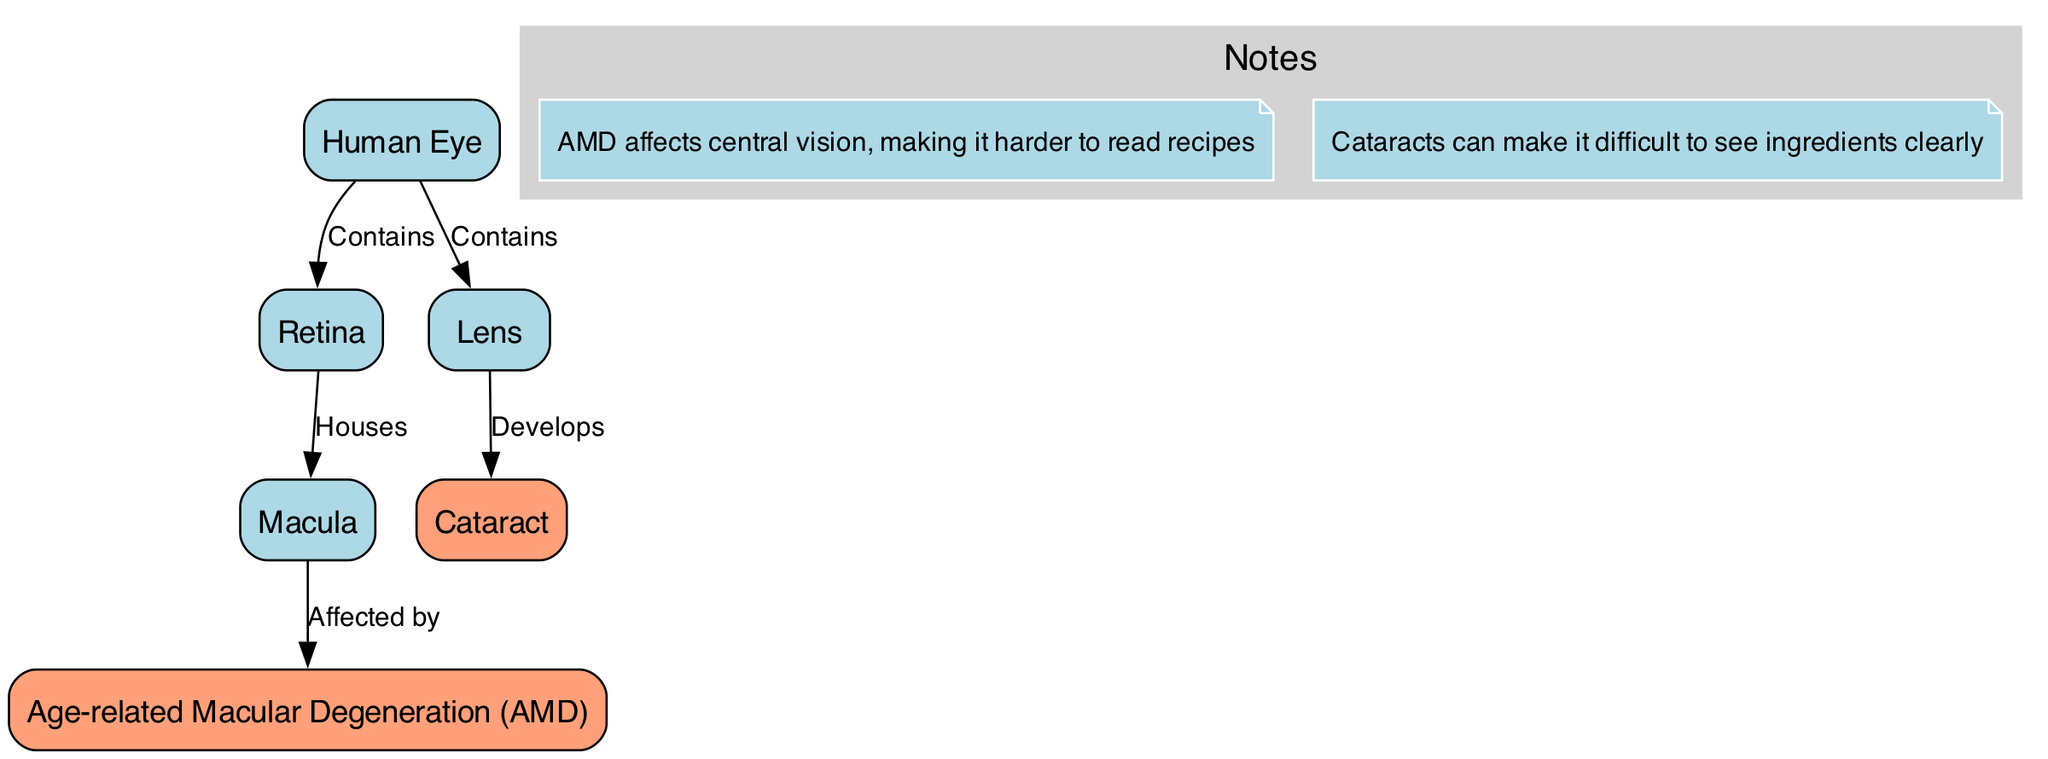What are the two main conditions depicted in the diagram? The diagram features two main conditions: Age-related Macular Degeneration (AMD) and Cataract, which are specified as nodes in the structure.
Answer: Age-related Macular Degeneration, Cataract How many nodes are present in the diagram? By counting the nodes listed in the diagram, we find six in total: Human Eye, Retina, Macula, Age-related Macular Degeneration, Lens, and Cataract.
Answer: 6 What relationship is shown between the Macula and Age-related Macular Degeneration? The diagram indicates that the Macula is affected by Age-related Macular Degeneration, signified by the directional edge from the Macula to the AMD node labeled "Affected by."
Answer: Affected by Which part of the eye contains the Lens according to the diagram? The diagram states that the Human Eye contains the Lens, with a direct edge linking the Eye node to the Lens node labeled "Contains."
Answer: Human Eye What is the effect of Cataracts as noted in the diagram? The annotation in the diagram explains that Cataracts can make it difficult to see ingredients clearly, providing a specific effect of this condition.
Answer: Difficult to see ingredients clearly What connects the Retina and the Macula in the diagram? The edge from the Retina to the Macula is labeled "Houses," signifying a direct relationship where the Retina houses the Macula, thus connecting these two nodes.
Answer: Houses What type of vision does AMD affect? The annotation notes mention that AMD affects central vision, which highlights its impact on the ability to read and perform tasks requiring sharp vision.
Answer: Central vision What does the Lens develop into? The diagram specifies that the Lens develops Cataracts, indicated by the edge labeled "Develops" that connects these two nodes.
Answer: Cataract 